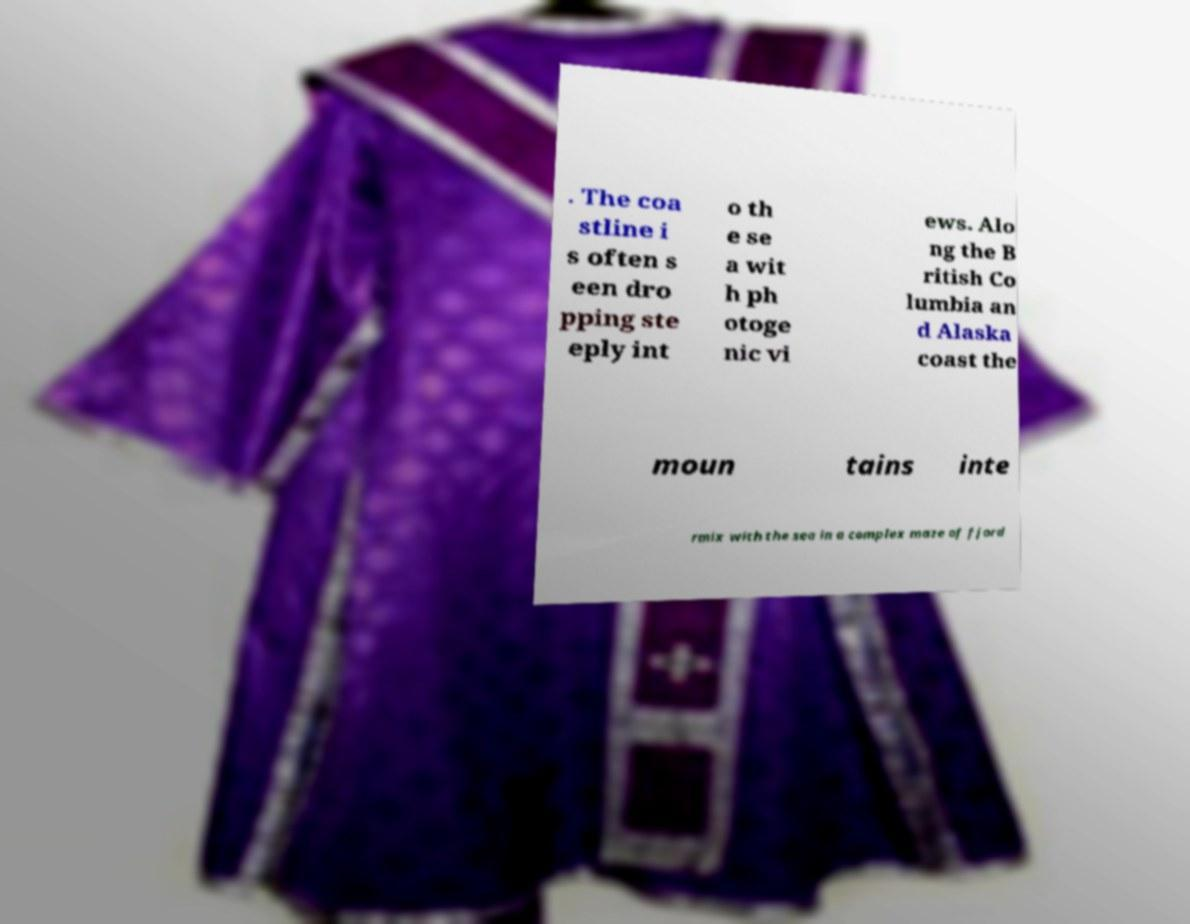I need the written content from this picture converted into text. Can you do that? . The coa stline i s often s een dro pping ste eply int o th e se a wit h ph otoge nic vi ews. Alo ng the B ritish Co lumbia an d Alaska coast the moun tains inte rmix with the sea in a complex maze of fjord 